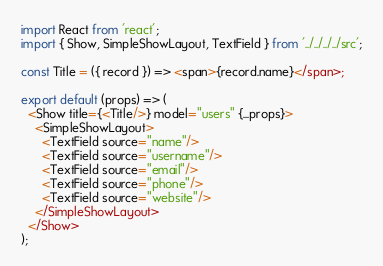Convert code to text. <code><loc_0><loc_0><loc_500><loc_500><_JavaScript_>import React from 'react';
import { Show, SimpleShowLayout, TextField } from '../../../../src';

const Title = ({ record }) => <span>{record.name}</span>;

export default (props) => (
  <Show title={<Title/>} model="users" {...props}>
    <SimpleShowLayout>
      <TextField source="name"/>
      <TextField source="username"/>
      <TextField source="email"/>
      <TextField source="phone"/>
      <TextField source="website"/>
    </SimpleShowLayout>
  </Show>
);</code> 